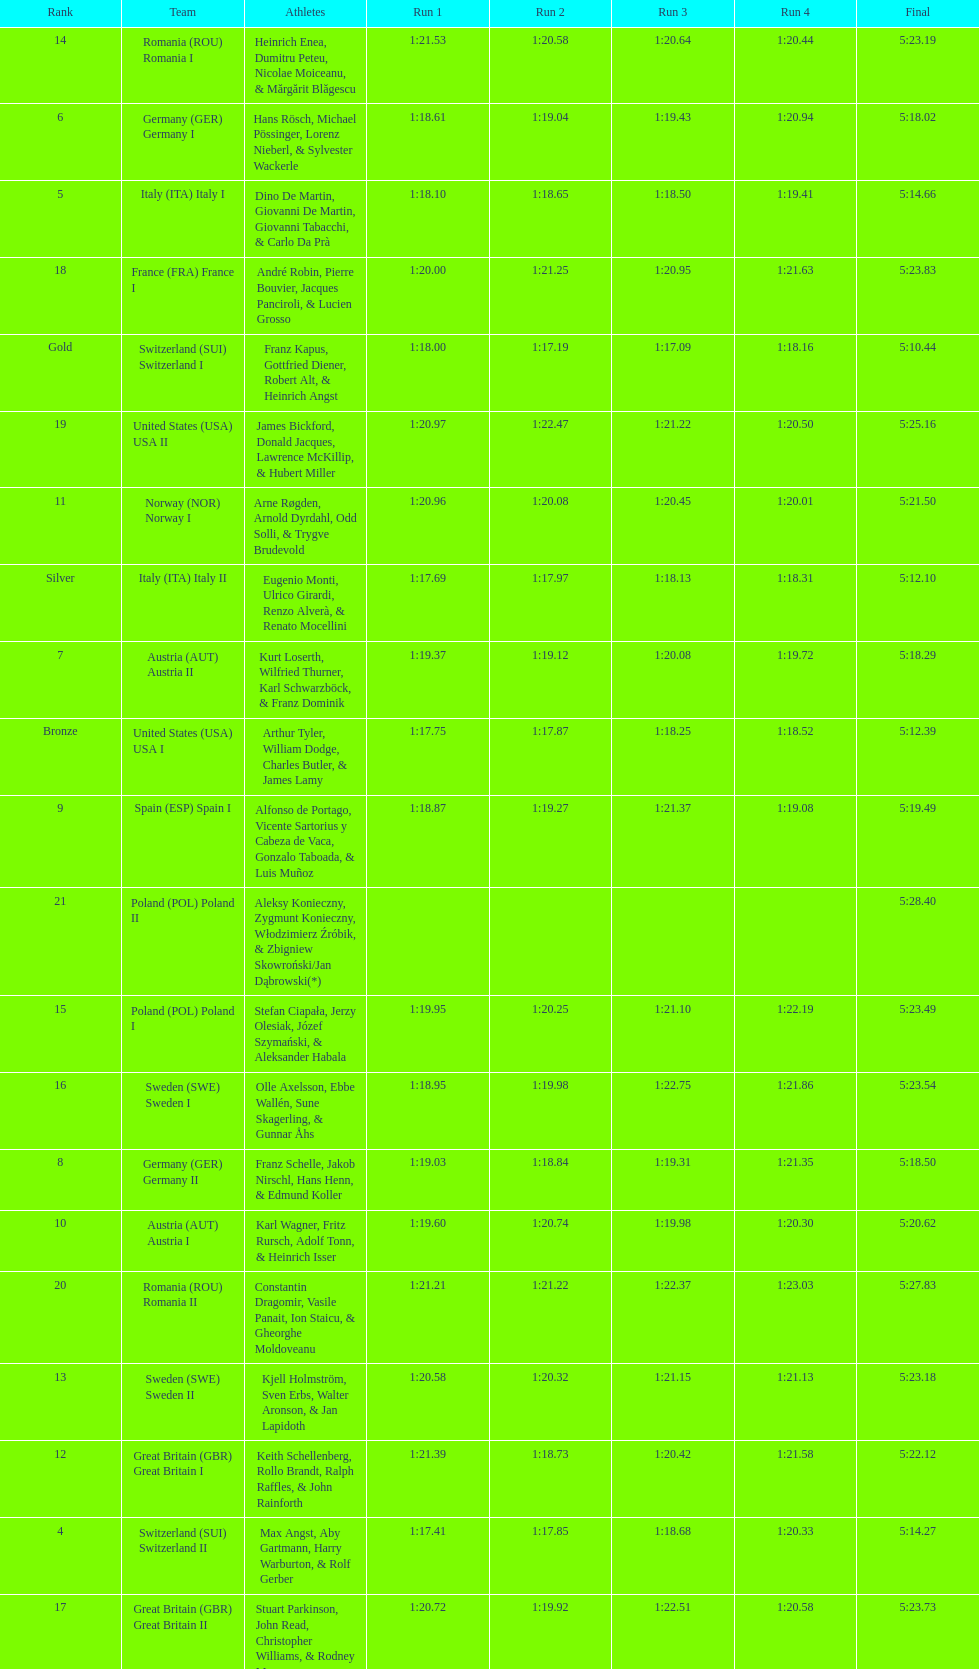Who is the previous team to italy (ita) italy ii? Switzerland (SUI) Switzerland I. 